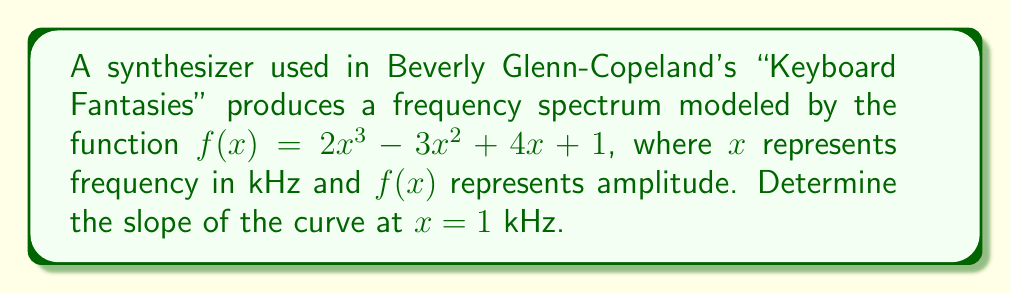Help me with this question. To find the slope of the curve at a specific point, we need to calculate the derivative of the function and evaluate it at the given point. Let's follow these steps:

1) The given function is $f(x) = 2x^3 - 3x^2 + 4x + 1$

2) To find the derivative, we apply the power rule and the constant rule:
   $$f'(x) = 6x^2 - 6x + 4$$

3) We're asked to find the slope at $x = 1$ kHz, so we need to evaluate $f'(1)$:
   $$f'(1) = 6(1)^2 - 6(1) + 4$$
   $$f'(1) = 6 - 6 + 4$$
   $$f'(1) = 4$$

4) The slope of the curve at $x = 1$ kHz is therefore 4.

This slope represents the rate of change of the amplitude with respect to frequency at 1 kHz, which is a crucial characteristic of the synthesizer's sound in "Keyboard Fantasies".
Answer: 4 